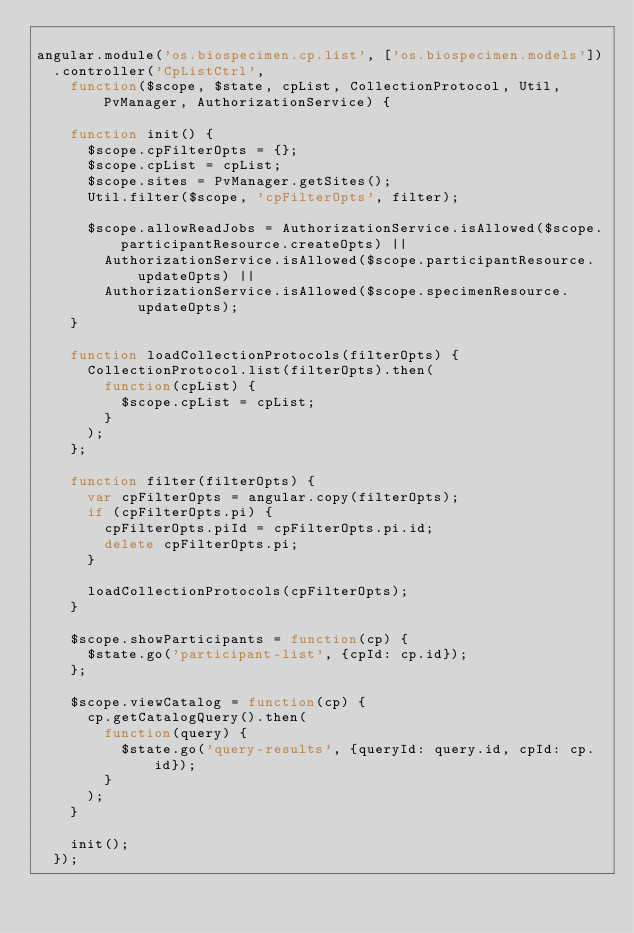Convert code to text. <code><loc_0><loc_0><loc_500><loc_500><_JavaScript_>
angular.module('os.biospecimen.cp.list', ['os.biospecimen.models'])
  .controller('CpListCtrl', 
    function($scope, $state, cpList, CollectionProtocol, Util, PvManager, AuthorizationService) {

    function init() {
      $scope.cpFilterOpts = {};
      $scope.cpList = cpList;
      $scope.sites = PvManager.getSites();
      Util.filter($scope, 'cpFilterOpts', filter);

      $scope.allowReadJobs = AuthorizationService.isAllowed($scope.participantResource.createOpts) ||
        AuthorizationService.isAllowed($scope.participantResource.updateOpts) ||
        AuthorizationService.isAllowed($scope.specimenResource.updateOpts);
    }

    function loadCollectionProtocols(filterOpts) {
      CollectionProtocol.list(filterOpts).then(
        function(cpList) {
          $scope.cpList = cpList;
        }
      );
    };

    function filter(filterOpts) {
      var cpFilterOpts = angular.copy(filterOpts);
      if (cpFilterOpts.pi) {
        cpFilterOpts.piId = cpFilterOpts.pi.id;
        delete cpFilterOpts.pi;
      }

      loadCollectionProtocols(cpFilterOpts);
    }

    $scope.showParticipants = function(cp) {
      $state.go('participant-list', {cpId: cp.id});
    };

    $scope.viewCatalog = function(cp) {
      cp.getCatalogQuery().then(
        function(query) {
          $state.go('query-results', {queryId: query.id, cpId: cp.id});
        }
      );
    }

    init();
  });
</code> 